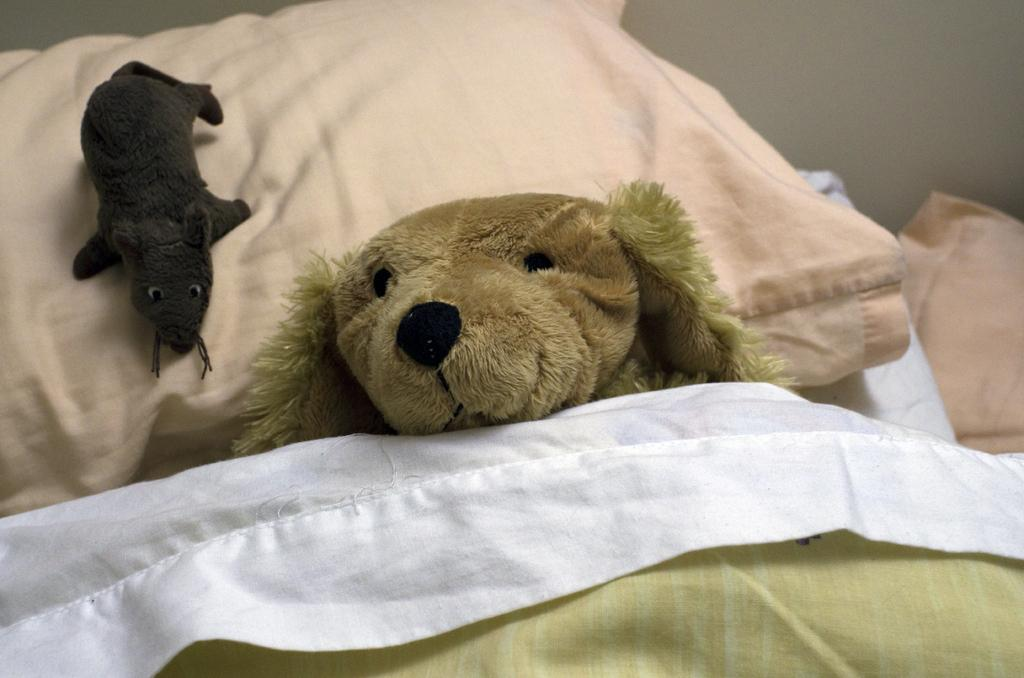What piece of furniture is in the image? There is a bed in the image. What is placed on top of the bed? A pillow is placed on the bed. What type of objects can be seen on the bed? There are two toys on the bed. What covers the bed in the image? A bed sheet is present on the bed. What can be seen in the background of the image? There is a wall visible in the image. What type of bag is being used for teaching in the image? There is no bag or teaching activity present in the image. 